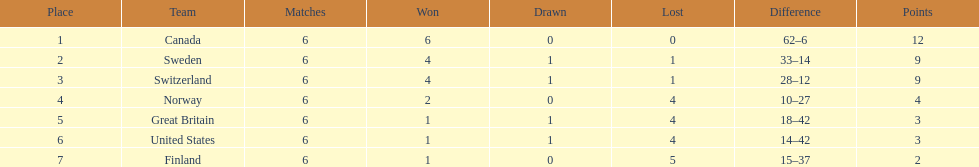Which country conceded the least goals? Finland. 